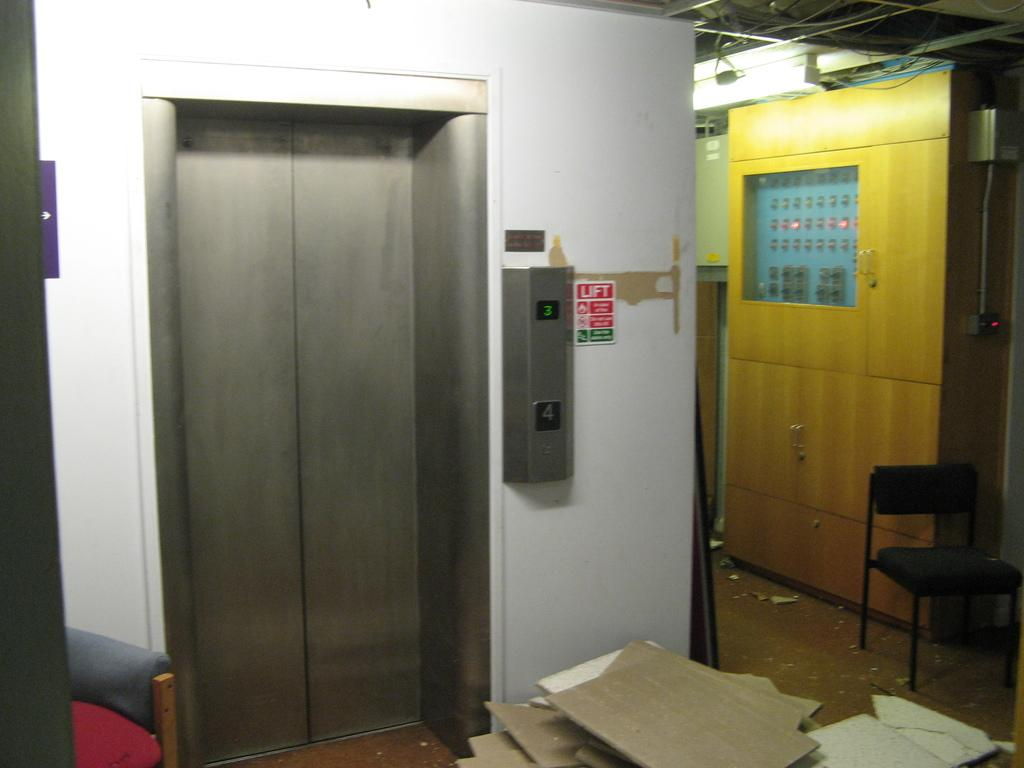What is on the floor in front of the lift door in the image? There are cardboard pieces on the floor in front of the lift door. What can be seen on the right side of the image? There is a chair and a row with many buttons on the right side of the image. What type of house is visible in the image? There is no house present in the image; it features a lift door, cardboard pieces, a chair, and a row of buttons. Can you see any twigs in the image? There are no twigs present in the image. 